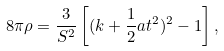<formula> <loc_0><loc_0><loc_500><loc_500>8 \pi \rho = \frac { 3 } { S ^ { 2 } } \left [ ( k + \frac { 1 } { 2 } a t ^ { 2 } ) ^ { 2 } - 1 \right ] ,</formula> 